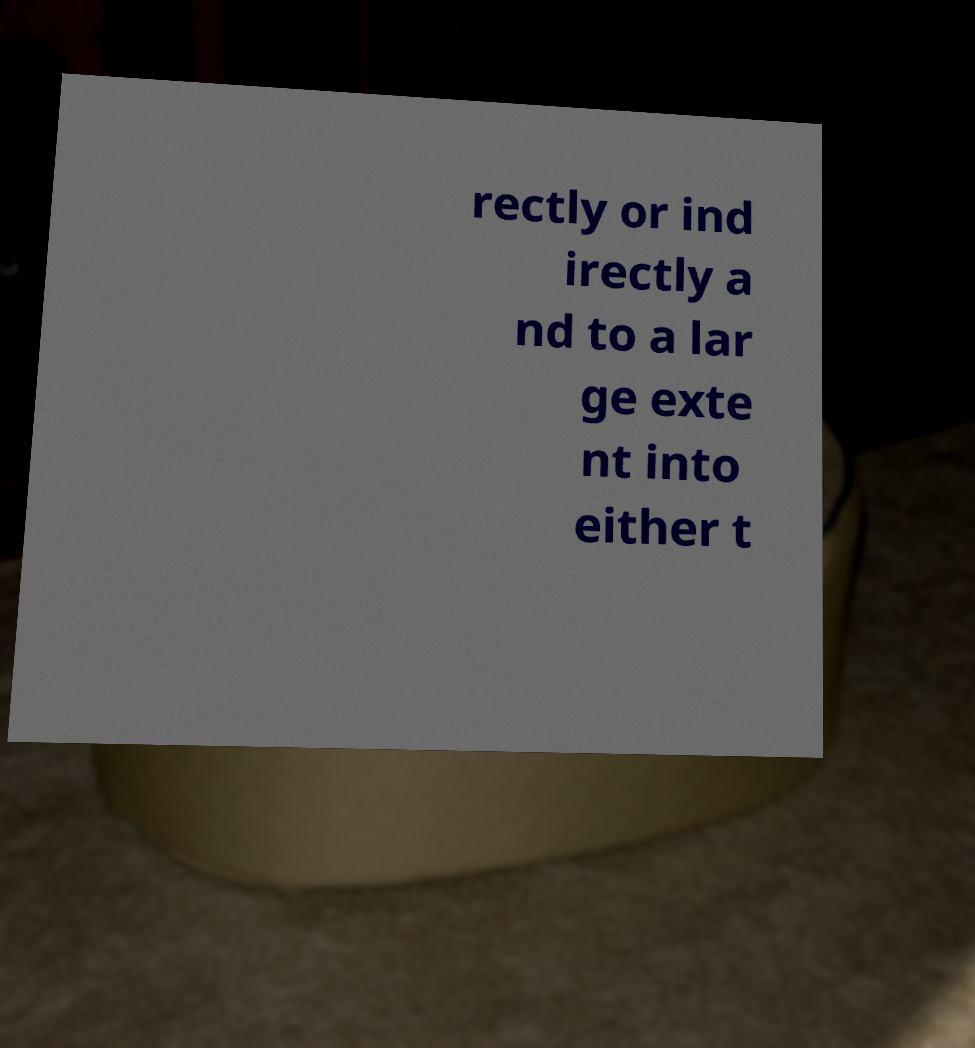For documentation purposes, I need the text within this image transcribed. Could you provide that? rectly or ind irectly a nd to a lar ge exte nt into either t 